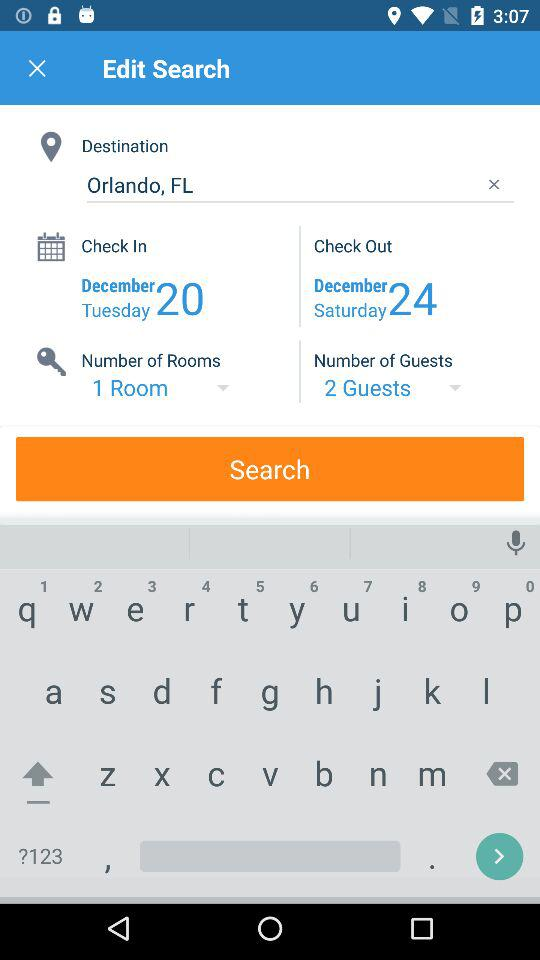What is the number of guests? The number of guests is 2. 